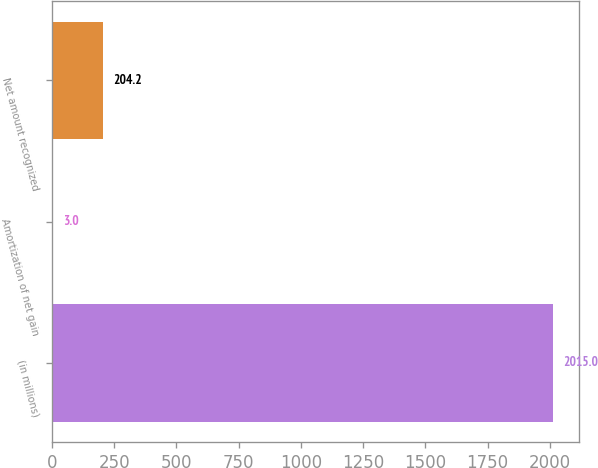<chart> <loc_0><loc_0><loc_500><loc_500><bar_chart><fcel>(in millions)<fcel>Amortization of net gain<fcel>Net amount recognized<nl><fcel>2015<fcel>3<fcel>204.2<nl></chart> 